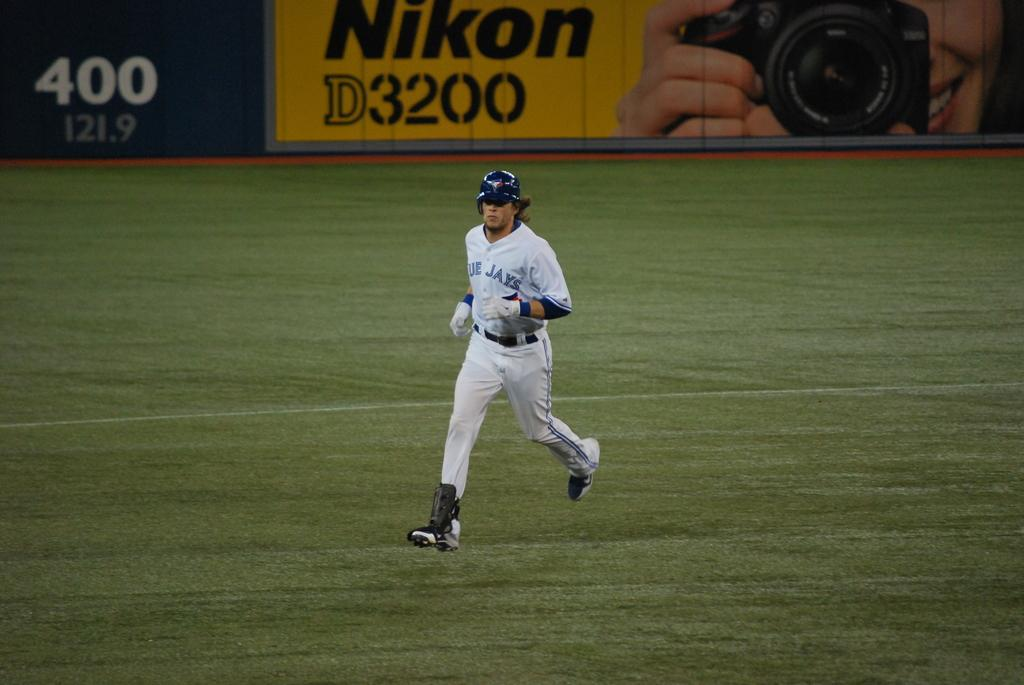Provide a one-sentence caption for the provided image. A Blue Jays player runs across the grassy field. 